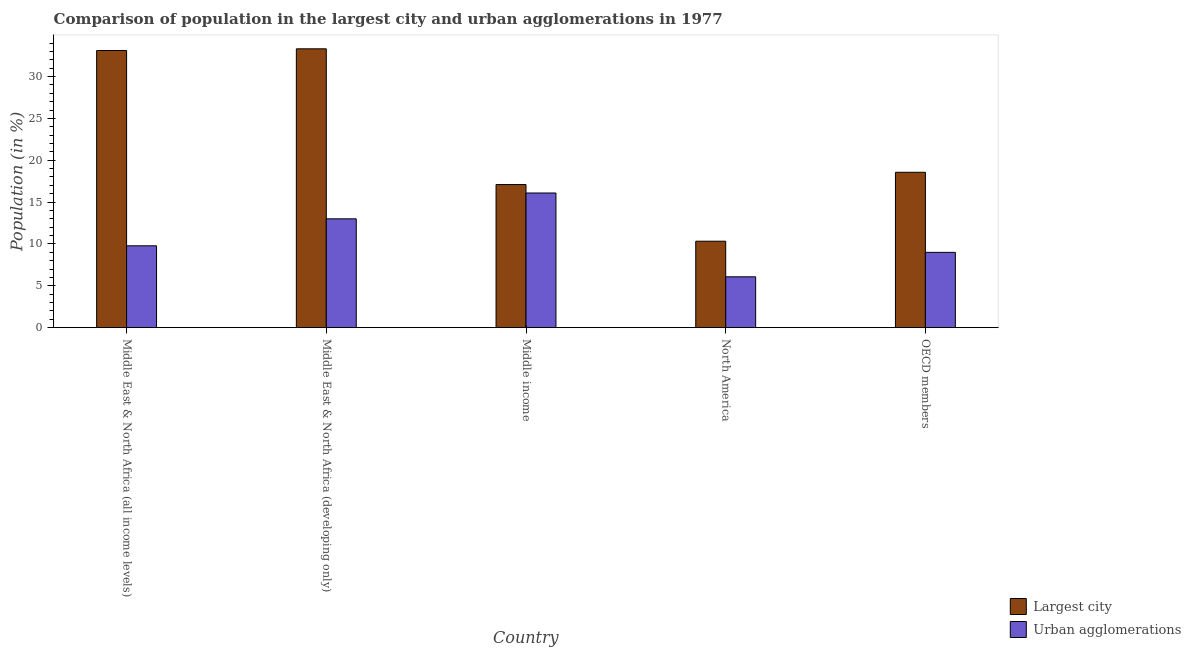How many different coloured bars are there?
Your answer should be compact. 2. How many groups of bars are there?
Make the answer very short. 5. Are the number of bars on each tick of the X-axis equal?
Give a very brief answer. Yes. How many bars are there on the 2nd tick from the left?
Provide a short and direct response. 2. How many bars are there on the 4th tick from the right?
Your response must be concise. 2. What is the label of the 2nd group of bars from the left?
Make the answer very short. Middle East & North Africa (developing only). What is the population in the largest city in OECD members?
Offer a terse response. 18.56. Across all countries, what is the maximum population in the largest city?
Your answer should be very brief. 33.31. Across all countries, what is the minimum population in the largest city?
Make the answer very short. 10.33. In which country was the population in the largest city maximum?
Give a very brief answer. Middle East & North Africa (developing only). In which country was the population in urban agglomerations minimum?
Offer a terse response. North America. What is the total population in the largest city in the graph?
Make the answer very short. 112.41. What is the difference between the population in urban agglomerations in Middle East & North Africa (all income levels) and that in Middle East & North Africa (developing only)?
Offer a very short reply. -3.22. What is the difference between the population in the largest city in OECD members and the population in urban agglomerations in North America?
Your answer should be very brief. 12.49. What is the average population in urban agglomerations per country?
Provide a short and direct response. 10.79. What is the difference between the population in urban agglomerations and population in the largest city in Middle income?
Offer a very short reply. -1.01. What is the ratio of the population in urban agglomerations in Middle East & North Africa (all income levels) to that in Middle income?
Keep it short and to the point. 0.61. Is the population in urban agglomerations in North America less than that in OECD members?
Ensure brevity in your answer.  Yes. What is the difference between the highest and the second highest population in the largest city?
Make the answer very short. 0.2. What is the difference between the highest and the lowest population in the largest city?
Offer a very short reply. 22.98. In how many countries, is the population in urban agglomerations greater than the average population in urban agglomerations taken over all countries?
Give a very brief answer. 2. Is the sum of the population in urban agglomerations in Middle income and North America greater than the maximum population in the largest city across all countries?
Keep it short and to the point. No. What does the 2nd bar from the left in Middle East & North Africa (developing only) represents?
Keep it short and to the point. Urban agglomerations. What does the 2nd bar from the right in Middle income represents?
Offer a very short reply. Largest city. How many bars are there?
Your answer should be very brief. 10. What is the difference between two consecutive major ticks on the Y-axis?
Your response must be concise. 5. How many legend labels are there?
Provide a short and direct response. 2. What is the title of the graph?
Provide a succinct answer. Comparison of population in the largest city and urban agglomerations in 1977. Does "Drinking water services" appear as one of the legend labels in the graph?
Your answer should be very brief. No. What is the label or title of the Y-axis?
Offer a very short reply. Population (in %). What is the Population (in %) of Largest city in Middle East & North Africa (all income levels)?
Give a very brief answer. 33.11. What is the Population (in %) in Urban agglomerations in Middle East & North Africa (all income levels)?
Give a very brief answer. 9.78. What is the Population (in %) in Largest city in Middle East & North Africa (developing only)?
Provide a succinct answer. 33.31. What is the Population (in %) of Urban agglomerations in Middle East & North Africa (developing only)?
Provide a short and direct response. 13. What is the Population (in %) of Largest city in Middle income?
Keep it short and to the point. 17.1. What is the Population (in %) in Urban agglomerations in Middle income?
Your answer should be compact. 16.09. What is the Population (in %) of Largest city in North America?
Your answer should be very brief. 10.33. What is the Population (in %) in Urban agglomerations in North America?
Your answer should be compact. 6.07. What is the Population (in %) of Largest city in OECD members?
Your answer should be very brief. 18.56. What is the Population (in %) in Urban agglomerations in OECD members?
Offer a terse response. 9. Across all countries, what is the maximum Population (in %) in Largest city?
Your answer should be very brief. 33.31. Across all countries, what is the maximum Population (in %) of Urban agglomerations?
Make the answer very short. 16.09. Across all countries, what is the minimum Population (in %) of Largest city?
Ensure brevity in your answer.  10.33. Across all countries, what is the minimum Population (in %) in Urban agglomerations?
Make the answer very short. 6.07. What is the total Population (in %) in Largest city in the graph?
Give a very brief answer. 112.41. What is the total Population (in %) in Urban agglomerations in the graph?
Give a very brief answer. 53.94. What is the difference between the Population (in %) of Largest city in Middle East & North Africa (all income levels) and that in Middle East & North Africa (developing only)?
Keep it short and to the point. -0.2. What is the difference between the Population (in %) of Urban agglomerations in Middle East & North Africa (all income levels) and that in Middle East & North Africa (developing only)?
Keep it short and to the point. -3.22. What is the difference between the Population (in %) of Largest city in Middle East & North Africa (all income levels) and that in Middle income?
Keep it short and to the point. 16.01. What is the difference between the Population (in %) in Urban agglomerations in Middle East & North Africa (all income levels) and that in Middle income?
Your response must be concise. -6.31. What is the difference between the Population (in %) in Largest city in Middle East & North Africa (all income levels) and that in North America?
Provide a succinct answer. 22.78. What is the difference between the Population (in %) in Urban agglomerations in Middle East & North Africa (all income levels) and that in North America?
Ensure brevity in your answer.  3.7. What is the difference between the Population (in %) in Largest city in Middle East & North Africa (all income levels) and that in OECD members?
Make the answer very short. 14.55. What is the difference between the Population (in %) of Urban agglomerations in Middle East & North Africa (all income levels) and that in OECD members?
Ensure brevity in your answer.  0.78. What is the difference between the Population (in %) of Largest city in Middle East & North Africa (developing only) and that in Middle income?
Keep it short and to the point. 16.22. What is the difference between the Population (in %) in Urban agglomerations in Middle East & North Africa (developing only) and that in Middle income?
Provide a succinct answer. -3.09. What is the difference between the Population (in %) in Largest city in Middle East & North Africa (developing only) and that in North America?
Give a very brief answer. 22.98. What is the difference between the Population (in %) in Urban agglomerations in Middle East & North Africa (developing only) and that in North America?
Your answer should be very brief. 6.93. What is the difference between the Population (in %) of Largest city in Middle East & North Africa (developing only) and that in OECD members?
Your answer should be compact. 14.75. What is the difference between the Population (in %) of Urban agglomerations in Middle East & North Africa (developing only) and that in OECD members?
Your answer should be very brief. 4.01. What is the difference between the Population (in %) in Largest city in Middle income and that in North America?
Ensure brevity in your answer.  6.77. What is the difference between the Population (in %) in Urban agglomerations in Middle income and that in North America?
Provide a short and direct response. 10.01. What is the difference between the Population (in %) in Largest city in Middle income and that in OECD members?
Give a very brief answer. -1.47. What is the difference between the Population (in %) of Urban agglomerations in Middle income and that in OECD members?
Make the answer very short. 7.09. What is the difference between the Population (in %) of Largest city in North America and that in OECD members?
Offer a terse response. -8.23. What is the difference between the Population (in %) of Urban agglomerations in North America and that in OECD members?
Provide a short and direct response. -2.92. What is the difference between the Population (in %) of Largest city in Middle East & North Africa (all income levels) and the Population (in %) of Urban agglomerations in Middle East & North Africa (developing only)?
Make the answer very short. 20.11. What is the difference between the Population (in %) of Largest city in Middle East & North Africa (all income levels) and the Population (in %) of Urban agglomerations in Middle income?
Your response must be concise. 17.02. What is the difference between the Population (in %) in Largest city in Middle East & North Africa (all income levels) and the Population (in %) in Urban agglomerations in North America?
Keep it short and to the point. 27.04. What is the difference between the Population (in %) in Largest city in Middle East & North Africa (all income levels) and the Population (in %) in Urban agglomerations in OECD members?
Offer a very short reply. 24.11. What is the difference between the Population (in %) of Largest city in Middle East & North Africa (developing only) and the Population (in %) of Urban agglomerations in Middle income?
Provide a short and direct response. 17.22. What is the difference between the Population (in %) in Largest city in Middle East & North Africa (developing only) and the Population (in %) in Urban agglomerations in North America?
Ensure brevity in your answer.  27.24. What is the difference between the Population (in %) in Largest city in Middle East & North Africa (developing only) and the Population (in %) in Urban agglomerations in OECD members?
Provide a succinct answer. 24.32. What is the difference between the Population (in %) in Largest city in Middle income and the Population (in %) in Urban agglomerations in North America?
Give a very brief answer. 11.02. What is the difference between the Population (in %) in Largest city in Middle income and the Population (in %) in Urban agglomerations in OECD members?
Offer a terse response. 8.1. What is the difference between the Population (in %) in Largest city in North America and the Population (in %) in Urban agglomerations in OECD members?
Ensure brevity in your answer.  1.33. What is the average Population (in %) of Largest city per country?
Give a very brief answer. 22.48. What is the average Population (in %) of Urban agglomerations per country?
Provide a short and direct response. 10.79. What is the difference between the Population (in %) in Largest city and Population (in %) in Urban agglomerations in Middle East & North Africa (all income levels)?
Offer a terse response. 23.33. What is the difference between the Population (in %) in Largest city and Population (in %) in Urban agglomerations in Middle East & North Africa (developing only)?
Your answer should be very brief. 20.31. What is the difference between the Population (in %) of Largest city and Population (in %) of Urban agglomerations in Middle income?
Ensure brevity in your answer.  1.01. What is the difference between the Population (in %) of Largest city and Population (in %) of Urban agglomerations in North America?
Offer a very short reply. 4.25. What is the difference between the Population (in %) in Largest city and Population (in %) in Urban agglomerations in OECD members?
Provide a short and direct response. 9.56. What is the ratio of the Population (in %) of Largest city in Middle East & North Africa (all income levels) to that in Middle East & North Africa (developing only)?
Keep it short and to the point. 0.99. What is the ratio of the Population (in %) of Urban agglomerations in Middle East & North Africa (all income levels) to that in Middle East & North Africa (developing only)?
Your response must be concise. 0.75. What is the ratio of the Population (in %) of Largest city in Middle East & North Africa (all income levels) to that in Middle income?
Your response must be concise. 1.94. What is the ratio of the Population (in %) of Urban agglomerations in Middle East & North Africa (all income levels) to that in Middle income?
Keep it short and to the point. 0.61. What is the ratio of the Population (in %) of Largest city in Middle East & North Africa (all income levels) to that in North America?
Provide a short and direct response. 3.21. What is the ratio of the Population (in %) in Urban agglomerations in Middle East & North Africa (all income levels) to that in North America?
Make the answer very short. 1.61. What is the ratio of the Population (in %) of Largest city in Middle East & North Africa (all income levels) to that in OECD members?
Your answer should be compact. 1.78. What is the ratio of the Population (in %) in Urban agglomerations in Middle East & North Africa (all income levels) to that in OECD members?
Your response must be concise. 1.09. What is the ratio of the Population (in %) of Largest city in Middle East & North Africa (developing only) to that in Middle income?
Ensure brevity in your answer.  1.95. What is the ratio of the Population (in %) of Urban agglomerations in Middle East & North Africa (developing only) to that in Middle income?
Your response must be concise. 0.81. What is the ratio of the Population (in %) in Largest city in Middle East & North Africa (developing only) to that in North America?
Provide a short and direct response. 3.23. What is the ratio of the Population (in %) in Urban agglomerations in Middle East & North Africa (developing only) to that in North America?
Offer a very short reply. 2.14. What is the ratio of the Population (in %) in Largest city in Middle East & North Africa (developing only) to that in OECD members?
Offer a very short reply. 1.79. What is the ratio of the Population (in %) in Urban agglomerations in Middle East & North Africa (developing only) to that in OECD members?
Ensure brevity in your answer.  1.45. What is the ratio of the Population (in %) in Largest city in Middle income to that in North America?
Provide a short and direct response. 1.66. What is the ratio of the Population (in %) in Urban agglomerations in Middle income to that in North America?
Provide a short and direct response. 2.65. What is the ratio of the Population (in %) of Largest city in Middle income to that in OECD members?
Your answer should be compact. 0.92. What is the ratio of the Population (in %) of Urban agglomerations in Middle income to that in OECD members?
Keep it short and to the point. 1.79. What is the ratio of the Population (in %) of Largest city in North America to that in OECD members?
Provide a succinct answer. 0.56. What is the ratio of the Population (in %) of Urban agglomerations in North America to that in OECD members?
Make the answer very short. 0.68. What is the difference between the highest and the second highest Population (in %) of Largest city?
Offer a very short reply. 0.2. What is the difference between the highest and the second highest Population (in %) of Urban agglomerations?
Keep it short and to the point. 3.09. What is the difference between the highest and the lowest Population (in %) in Largest city?
Offer a very short reply. 22.98. What is the difference between the highest and the lowest Population (in %) in Urban agglomerations?
Give a very brief answer. 10.01. 